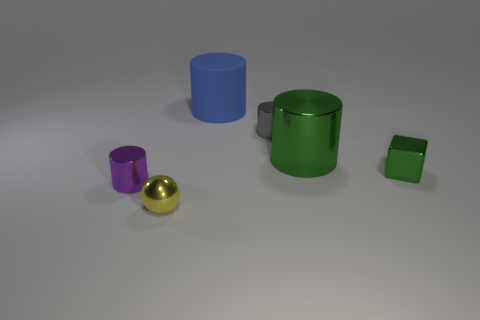Subtract all green cylinders. How many cylinders are left? 3 Add 3 green cubes. How many objects exist? 9 Subtract all spheres. How many objects are left? 5 Subtract all purple cylinders. How many cylinders are left? 3 Add 2 tiny blue shiny cylinders. How many tiny blue shiny cylinders exist? 2 Subtract 1 green blocks. How many objects are left? 5 Subtract 1 blocks. How many blocks are left? 0 Subtract all cyan cylinders. Subtract all brown balls. How many cylinders are left? 4 Subtract all blue blocks. How many purple cylinders are left? 1 Subtract all small gray metal things. Subtract all blue matte objects. How many objects are left? 4 